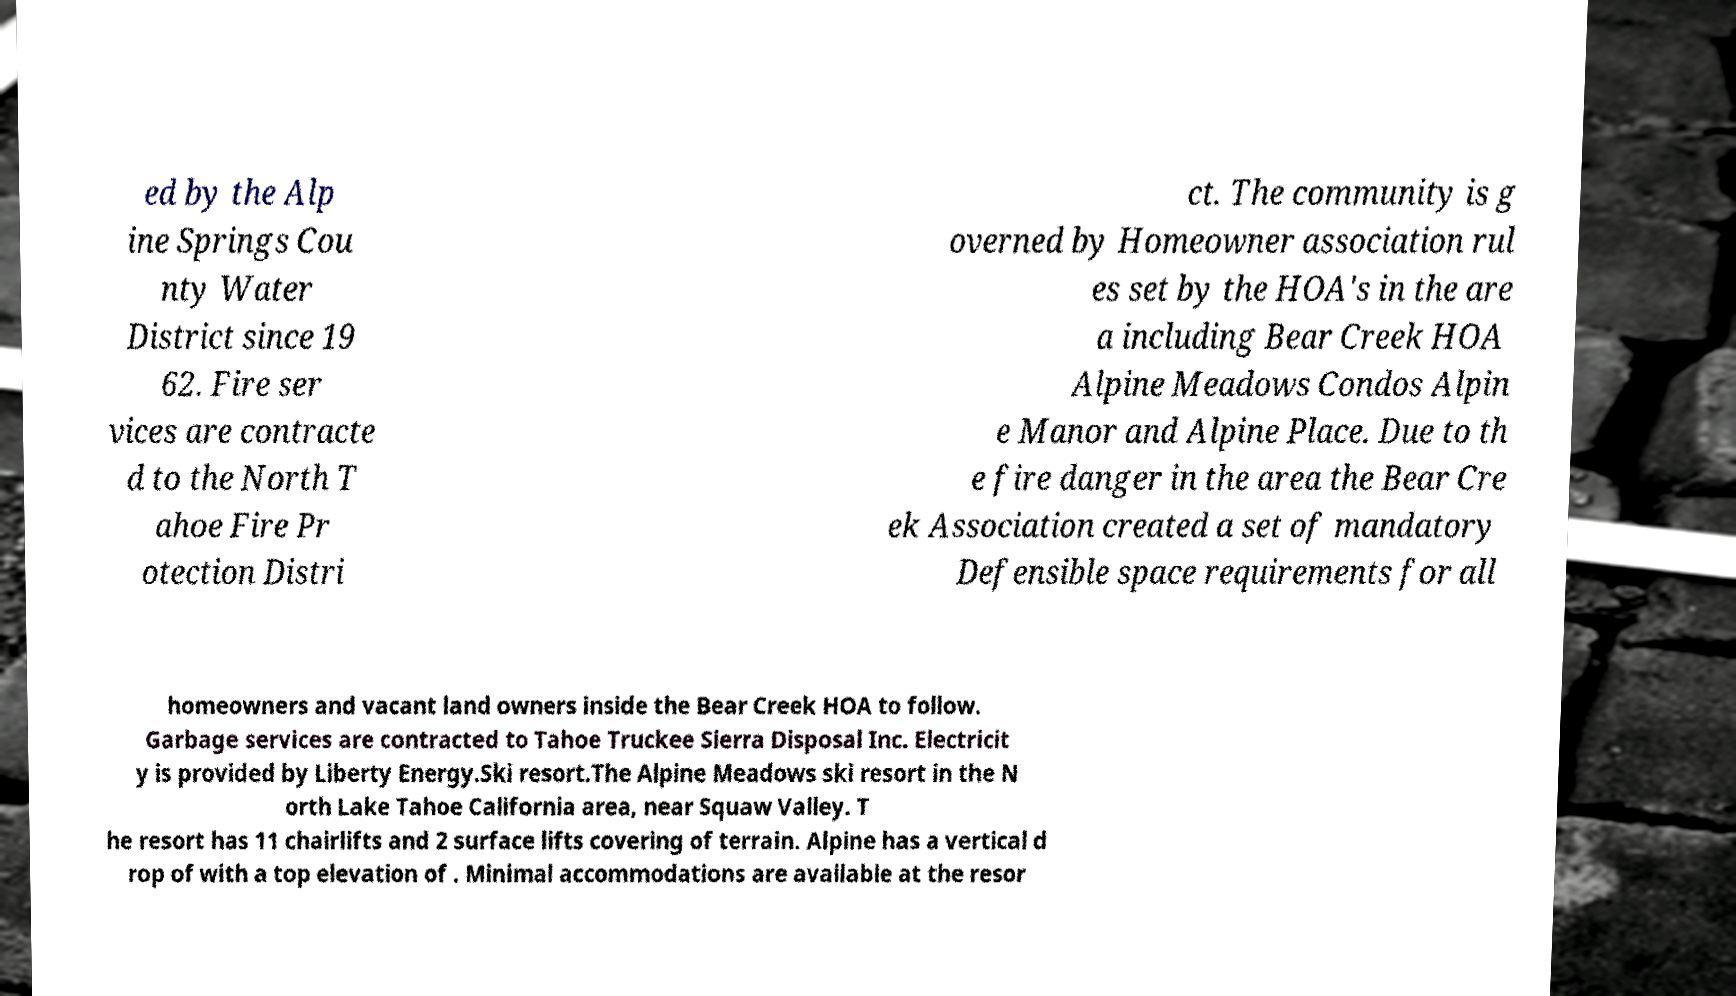Could you extract and type out the text from this image? ed by the Alp ine Springs Cou nty Water District since 19 62. Fire ser vices are contracte d to the North T ahoe Fire Pr otection Distri ct. The community is g overned by Homeowner association rul es set by the HOA's in the are a including Bear Creek HOA Alpine Meadows Condos Alpin e Manor and Alpine Place. Due to th e fire danger in the area the Bear Cre ek Association created a set of mandatory Defensible space requirements for all homeowners and vacant land owners inside the Bear Creek HOA to follow. Garbage services are contracted to Tahoe Truckee Sierra Disposal Inc. Electricit y is provided by Liberty Energy.Ski resort.The Alpine Meadows ski resort in the N orth Lake Tahoe California area, near Squaw Valley. T he resort has 11 chairlifts and 2 surface lifts covering of terrain. Alpine has a vertical d rop of with a top elevation of . Minimal accommodations are available at the resor 